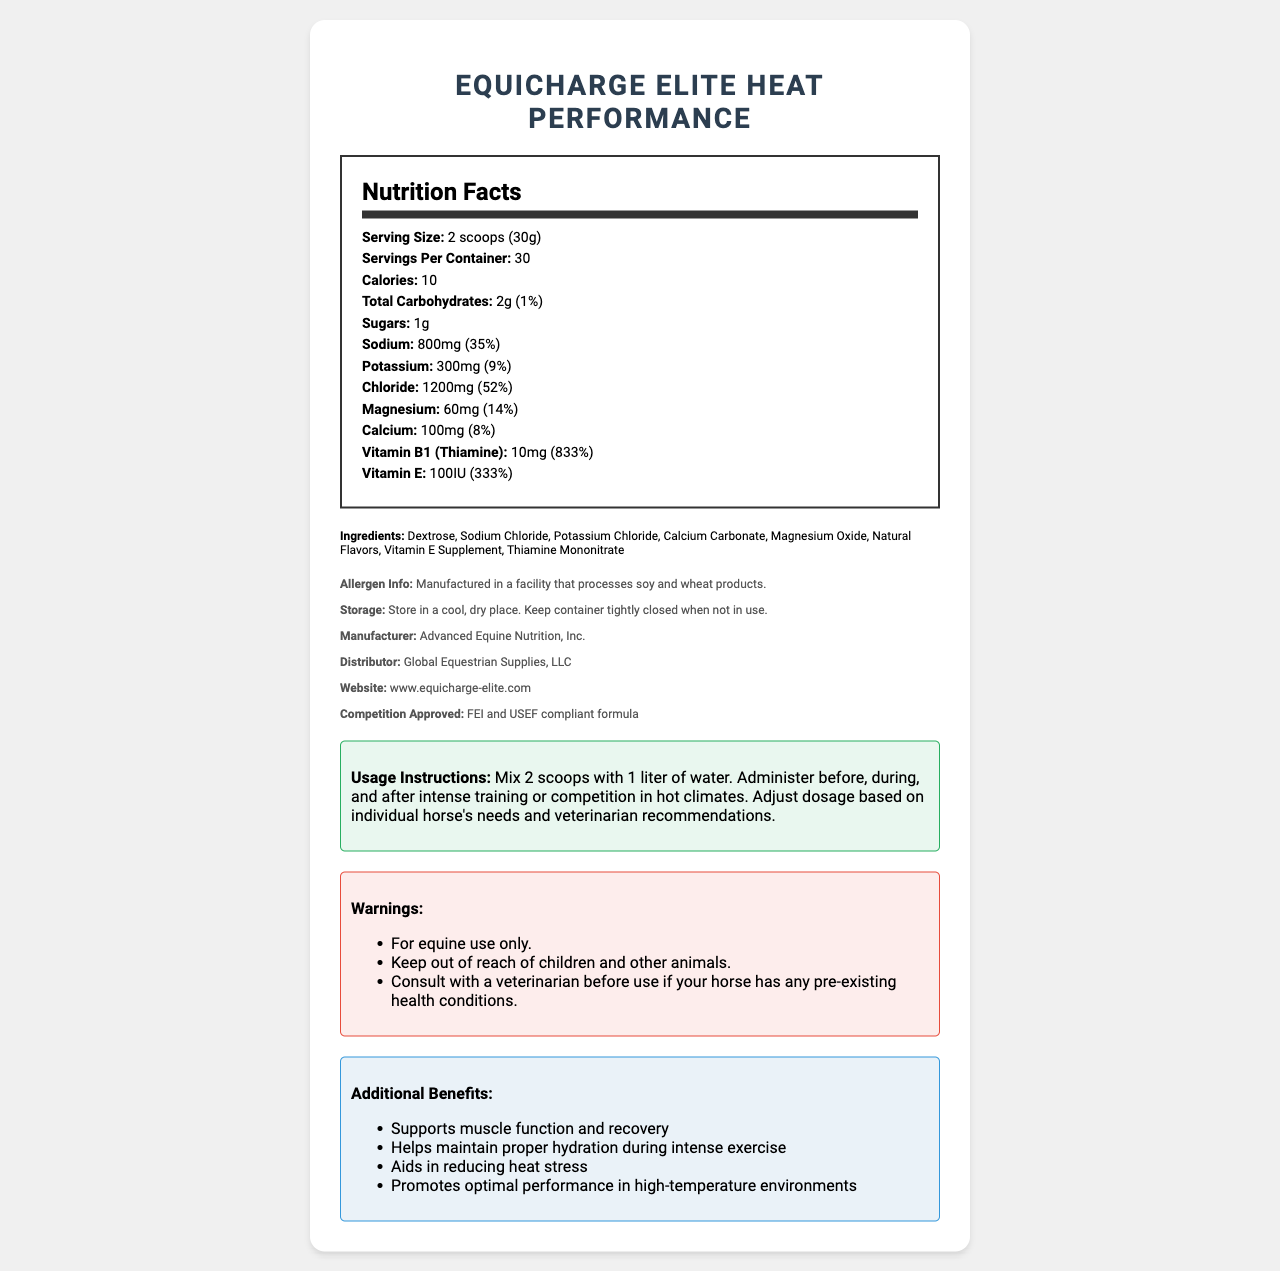what is the serving size of EquiCharge Elite Heat Performance? The document states the serving size as "2 scoops (30g)" right under the product name and title "Nutrition Facts".
Answer: 2 scoops (30g) how many calories are in one serving? The document directly lists the number of calories in one serving as "10".
Answer: 10 list three ingredients contained in this electrolyte powder. The section labeled "Ingredients" lists all of the components, from which Dextrose, Sodium Chloride, and Potassium Chloride are three examples.
Answer: Dextrose, Sodium Chloride, Potassium Chloride how much sodium does this product contain per serving? In the "Nutrition Facts" section, under "Sodium" it shows 800mg, 35% daily value.
Answer: 800mg (35% daily value) how many servings per container are there? The document lists "Servings Per Container" as 30.
Answer: 30 which mineral has the highest daily value percentage per serving? A. Potassium B. Chloride C. Magnesium D. Calcium Chloride has a daily value of 52%, which is the highest among the listed minerals.
Answer: B which vitamin is provided in the greatest amount relative to daily value? A. Vitamin B1 (Thiamine) B. Vitamin E C. Magnesium The document states Vitamin B1 (Thiamine) has a daily value of 833%, which is higher than Vitamin E's 333% and Magnesium's 14%.
Answer: A is this product suitable for animals other than horses? The warnings section clearly state that this product is for equine use only.
Answer: No briefly describe the main purpose of this document. The main purpose is to inform the user about the composition, benefits, and proper usage of the electrolyte powder specifically designed for horses competing in hot climates.
Answer: The document provides detailed nutritional information for the EquiCharge Elite Heat Performance electrolyte powder. It includes serving size, key nutrients, ingredients, allergen information, usage instructions, and manufacturer details. what is the daily value percentage of magnesium per serving? The "Nutrition Facts" section lists Magnesium as having a daily value of 14%.
Answer: 14% can the exact storage temperature for this product be determined from the document? The document only states to "Store in a cool, dry place" and does not provide a specific temperature range.
Answer: Not enough information 